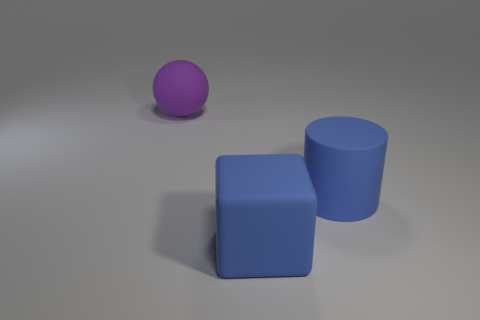Add 1 green metallic things. How many objects exist? 4 Subtract all cylinders. How many objects are left? 2 Add 1 yellow shiny cubes. How many yellow shiny cubes exist? 1 Subtract 0 green cylinders. How many objects are left? 3 Subtract all big purple things. Subtract all large cubes. How many objects are left? 1 Add 2 purple balls. How many purple balls are left? 3 